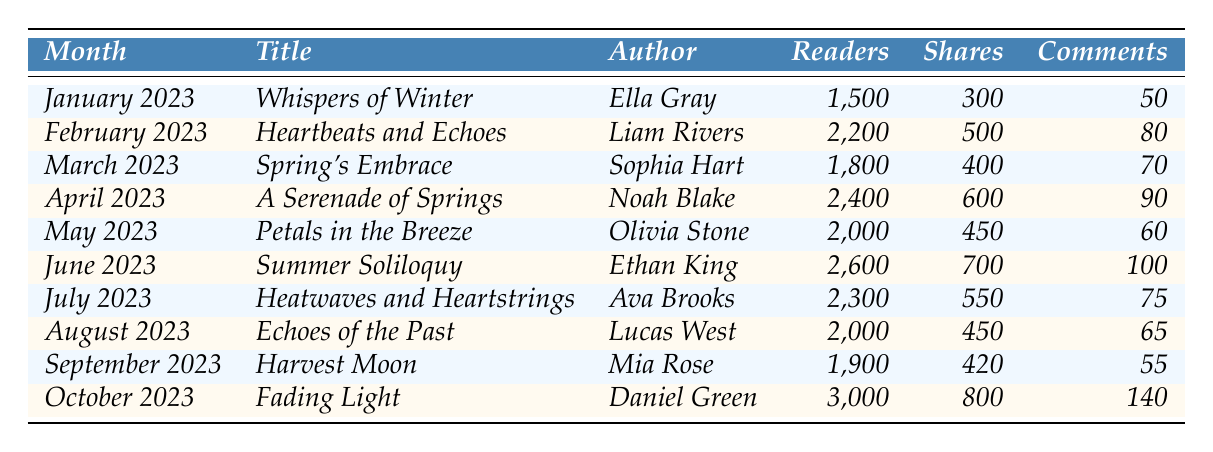What is the title of the article with the highest number of readers? The article with the highest number of readers is "Fading Light" in October 2023, which had 3,000 readers.
Answer: Fading Light How many shares did "Summer Soliloquy" receive? According to the table, "Summer Soliloquy" received 700 shares in June 2023.
Answer: 700 Which month had the lowest number of comments? Upon reviewing the comments, "Harvest Moon" in September 2023 had the fewest comments, totaling 55.
Answer: 55 What is the average number of readers across all articles? Adding the readers: 1500 + 2200 + 1800 + 2400 + 2000 + 2600 + 2300 + 2000 + 1900 + 3000 = 22,700. Divided by 10 articles, the average is 2270.
Answer: 2270 Did "Whispers of Winter" receive more readers than "Petals in the Breeze"? "Whispers of Winter" had 1500 readers, while "Petals in the Breeze" had 2000 readers. Therefore, the statement is false.
Answer: No Which author had the most comments in their article? "Fading Light" by Daniel Green had 140 comments, which is the highest compared to others.
Answer: Daniel Green What was the total number of shares for the articles in the first half of 2023? The shares for the first half: 300 + 500 + 400 + 600 + 450 + 700 = 2950.
Answer: 2950 Compare the number of readers between "A Serenade of Springs" and "Heatwaves and Heartstrings." "A Serenade of Springs" had 2400 readers while "Heatwaves and Heartstrings" had 2300 readers. Thus, "A Serenade of Springs" had 100 more readers.
Answer: 100 more readers Was there a month where comments exceeded shares? In April 2023, "A Serenade of Springs" had 90 comments while shares were 600. This instance qualifies as having comments below shares. Hence, the answer is no.
Answer: No How much did the readership increase from March to April 2023? The readership in March 2023 was 1800, which increased to 2400 in April 2023, a difference of 600 readers (2400 - 1800).
Answer: 600 readers 